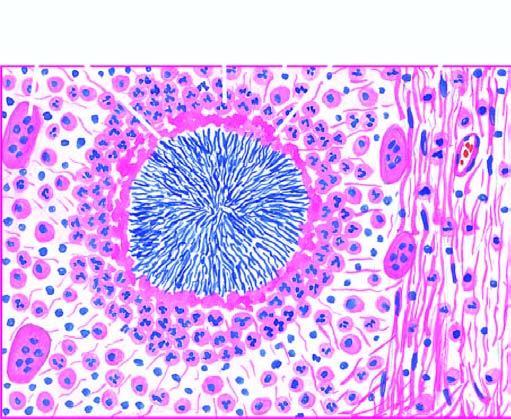does the margin of the colony show hyaline filaments highlighted by masson 's trichrome stain right photomicrograph?
Answer the question using a single word or phrase. Yes 